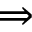Convert formula to latex. <formula><loc_0><loc_0><loc_500><loc_500>\Rightarrow</formula> 